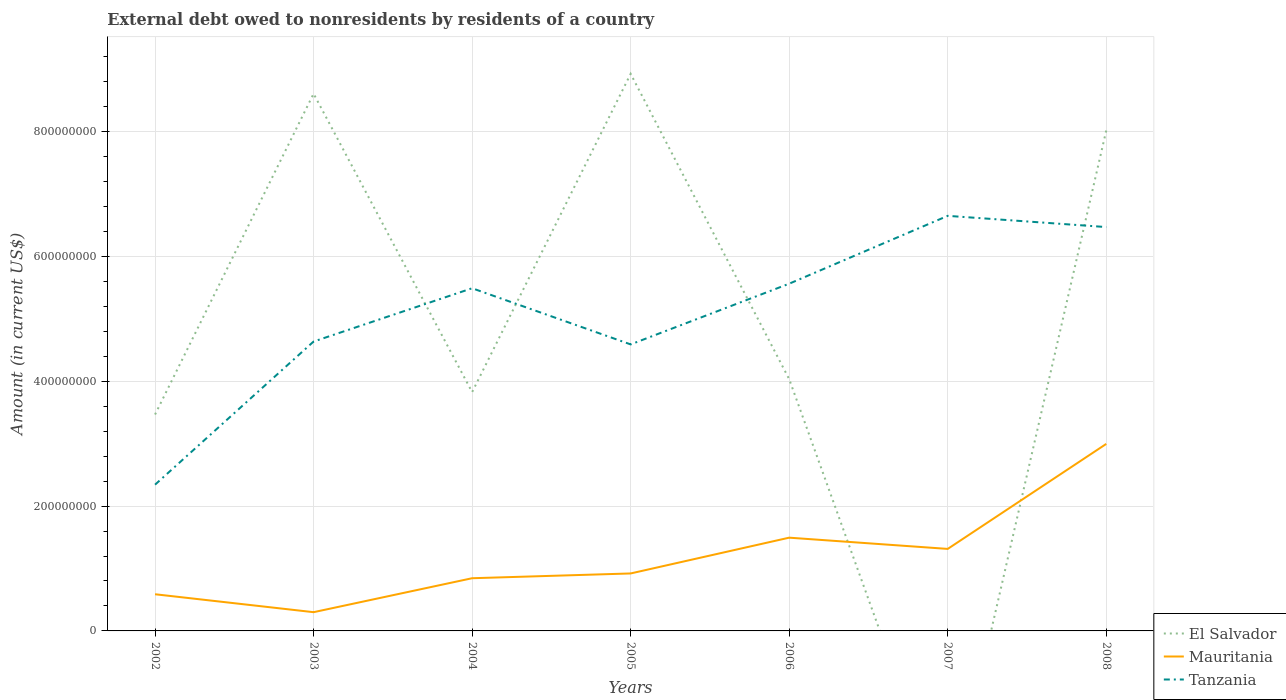How many different coloured lines are there?
Your response must be concise. 3. Does the line corresponding to Tanzania intersect with the line corresponding to Mauritania?
Keep it short and to the point. No. Is the number of lines equal to the number of legend labels?
Make the answer very short. No. Across all years, what is the maximum external debt owed by residents in Tanzania?
Your answer should be compact. 2.34e+08. What is the total external debt owed by residents in Mauritania in the graph?
Your answer should be very brief. -1.68e+08. What is the difference between the highest and the second highest external debt owed by residents in Mauritania?
Offer a very short reply. 2.70e+08. Is the external debt owed by residents in El Salvador strictly greater than the external debt owed by residents in Mauritania over the years?
Your response must be concise. No. How many lines are there?
Provide a short and direct response. 3. What is the difference between two consecutive major ticks on the Y-axis?
Provide a succinct answer. 2.00e+08. Does the graph contain any zero values?
Ensure brevity in your answer.  Yes. Where does the legend appear in the graph?
Provide a succinct answer. Bottom right. How many legend labels are there?
Ensure brevity in your answer.  3. What is the title of the graph?
Your answer should be very brief. External debt owed to nonresidents by residents of a country. What is the label or title of the Y-axis?
Offer a terse response. Amount (in current US$). What is the Amount (in current US$) of El Salvador in 2002?
Offer a very short reply. 3.47e+08. What is the Amount (in current US$) of Mauritania in 2002?
Give a very brief answer. 5.87e+07. What is the Amount (in current US$) in Tanzania in 2002?
Your answer should be very brief. 2.34e+08. What is the Amount (in current US$) in El Salvador in 2003?
Ensure brevity in your answer.  8.61e+08. What is the Amount (in current US$) of Mauritania in 2003?
Your answer should be compact. 3.00e+07. What is the Amount (in current US$) of Tanzania in 2003?
Ensure brevity in your answer.  4.64e+08. What is the Amount (in current US$) of El Salvador in 2004?
Keep it short and to the point. 3.83e+08. What is the Amount (in current US$) in Mauritania in 2004?
Keep it short and to the point. 8.44e+07. What is the Amount (in current US$) of Tanzania in 2004?
Provide a succinct answer. 5.49e+08. What is the Amount (in current US$) in El Salvador in 2005?
Make the answer very short. 8.92e+08. What is the Amount (in current US$) of Mauritania in 2005?
Keep it short and to the point. 9.21e+07. What is the Amount (in current US$) of Tanzania in 2005?
Your answer should be compact. 4.59e+08. What is the Amount (in current US$) in El Salvador in 2006?
Give a very brief answer. 4.03e+08. What is the Amount (in current US$) of Mauritania in 2006?
Offer a very short reply. 1.49e+08. What is the Amount (in current US$) in Tanzania in 2006?
Your answer should be compact. 5.56e+08. What is the Amount (in current US$) in El Salvador in 2007?
Your response must be concise. 0. What is the Amount (in current US$) of Mauritania in 2007?
Offer a very short reply. 1.31e+08. What is the Amount (in current US$) in Tanzania in 2007?
Your response must be concise. 6.65e+08. What is the Amount (in current US$) of El Salvador in 2008?
Make the answer very short. 8.02e+08. What is the Amount (in current US$) of Mauritania in 2008?
Your response must be concise. 3.00e+08. What is the Amount (in current US$) in Tanzania in 2008?
Keep it short and to the point. 6.47e+08. Across all years, what is the maximum Amount (in current US$) in El Salvador?
Your answer should be very brief. 8.92e+08. Across all years, what is the maximum Amount (in current US$) in Mauritania?
Make the answer very short. 3.00e+08. Across all years, what is the maximum Amount (in current US$) in Tanzania?
Provide a short and direct response. 6.65e+08. Across all years, what is the minimum Amount (in current US$) in Mauritania?
Provide a short and direct response. 3.00e+07. Across all years, what is the minimum Amount (in current US$) in Tanzania?
Ensure brevity in your answer.  2.34e+08. What is the total Amount (in current US$) in El Salvador in the graph?
Offer a very short reply. 3.69e+09. What is the total Amount (in current US$) of Mauritania in the graph?
Your response must be concise. 8.46e+08. What is the total Amount (in current US$) in Tanzania in the graph?
Offer a very short reply. 3.57e+09. What is the difference between the Amount (in current US$) in El Salvador in 2002 and that in 2003?
Provide a short and direct response. -5.14e+08. What is the difference between the Amount (in current US$) in Mauritania in 2002 and that in 2003?
Give a very brief answer. 2.87e+07. What is the difference between the Amount (in current US$) in Tanzania in 2002 and that in 2003?
Your answer should be compact. -2.29e+08. What is the difference between the Amount (in current US$) in El Salvador in 2002 and that in 2004?
Provide a short and direct response. -3.59e+07. What is the difference between the Amount (in current US$) of Mauritania in 2002 and that in 2004?
Make the answer very short. -2.57e+07. What is the difference between the Amount (in current US$) in Tanzania in 2002 and that in 2004?
Keep it short and to the point. -3.15e+08. What is the difference between the Amount (in current US$) of El Salvador in 2002 and that in 2005?
Your response must be concise. -5.46e+08. What is the difference between the Amount (in current US$) in Mauritania in 2002 and that in 2005?
Make the answer very short. -3.33e+07. What is the difference between the Amount (in current US$) of Tanzania in 2002 and that in 2005?
Provide a short and direct response. -2.25e+08. What is the difference between the Amount (in current US$) of El Salvador in 2002 and that in 2006?
Give a very brief answer. -5.66e+07. What is the difference between the Amount (in current US$) of Mauritania in 2002 and that in 2006?
Provide a short and direct response. -9.06e+07. What is the difference between the Amount (in current US$) in Tanzania in 2002 and that in 2006?
Provide a short and direct response. -3.22e+08. What is the difference between the Amount (in current US$) of Mauritania in 2002 and that in 2007?
Your answer should be very brief. -7.26e+07. What is the difference between the Amount (in current US$) in Tanzania in 2002 and that in 2007?
Ensure brevity in your answer.  -4.31e+08. What is the difference between the Amount (in current US$) in El Salvador in 2002 and that in 2008?
Your response must be concise. -4.55e+08. What is the difference between the Amount (in current US$) in Mauritania in 2002 and that in 2008?
Your answer should be compact. -2.41e+08. What is the difference between the Amount (in current US$) in Tanzania in 2002 and that in 2008?
Provide a short and direct response. -4.13e+08. What is the difference between the Amount (in current US$) in El Salvador in 2003 and that in 2004?
Give a very brief answer. 4.78e+08. What is the difference between the Amount (in current US$) in Mauritania in 2003 and that in 2004?
Give a very brief answer. -5.44e+07. What is the difference between the Amount (in current US$) of Tanzania in 2003 and that in 2004?
Your answer should be very brief. -8.54e+07. What is the difference between the Amount (in current US$) of El Salvador in 2003 and that in 2005?
Make the answer very short. -3.18e+07. What is the difference between the Amount (in current US$) of Mauritania in 2003 and that in 2005?
Make the answer very short. -6.20e+07. What is the difference between the Amount (in current US$) in Tanzania in 2003 and that in 2005?
Your answer should be very brief. 4.60e+06. What is the difference between the Amount (in current US$) in El Salvador in 2003 and that in 2006?
Give a very brief answer. 4.57e+08. What is the difference between the Amount (in current US$) of Mauritania in 2003 and that in 2006?
Make the answer very short. -1.19e+08. What is the difference between the Amount (in current US$) of Tanzania in 2003 and that in 2006?
Make the answer very short. -9.27e+07. What is the difference between the Amount (in current US$) of Mauritania in 2003 and that in 2007?
Give a very brief answer. -1.01e+08. What is the difference between the Amount (in current US$) in Tanzania in 2003 and that in 2007?
Your answer should be very brief. -2.01e+08. What is the difference between the Amount (in current US$) of El Salvador in 2003 and that in 2008?
Keep it short and to the point. 5.88e+07. What is the difference between the Amount (in current US$) of Mauritania in 2003 and that in 2008?
Ensure brevity in your answer.  -2.70e+08. What is the difference between the Amount (in current US$) in Tanzania in 2003 and that in 2008?
Ensure brevity in your answer.  -1.83e+08. What is the difference between the Amount (in current US$) in El Salvador in 2004 and that in 2005?
Your response must be concise. -5.10e+08. What is the difference between the Amount (in current US$) of Mauritania in 2004 and that in 2005?
Provide a short and direct response. -7.65e+06. What is the difference between the Amount (in current US$) in Tanzania in 2004 and that in 2005?
Offer a terse response. 9.00e+07. What is the difference between the Amount (in current US$) of El Salvador in 2004 and that in 2006?
Give a very brief answer. -2.07e+07. What is the difference between the Amount (in current US$) in Mauritania in 2004 and that in 2006?
Offer a terse response. -6.50e+07. What is the difference between the Amount (in current US$) in Tanzania in 2004 and that in 2006?
Keep it short and to the point. -7.30e+06. What is the difference between the Amount (in current US$) of Mauritania in 2004 and that in 2007?
Your response must be concise. -4.70e+07. What is the difference between the Amount (in current US$) of Tanzania in 2004 and that in 2007?
Offer a very short reply. -1.16e+08. What is the difference between the Amount (in current US$) in El Salvador in 2004 and that in 2008?
Provide a succinct answer. -4.19e+08. What is the difference between the Amount (in current US$) of Mauritania in 2004 and that in 2008?
Offer a terse response. -2.15e+08. What is the difference between the Amount (in current US$) in Tanzania in 2004 and that in 2008?
Your answer should be very brief. -9.80e+07. What is the difference between the Amount (in current US$) in El Salvador in 2005 and that in 2006?
Offer a very short reply. 4.89e+08. What is the difference between the Amount (in current US$) in Mauritania in 2005 and that in 2006?
Make the answer very short. -5.73e+07. What is the difference between the Amount (in current US$) of Tanzania in 2005 and that in 2006?
Provide a succinct answer. -9.73e+07. What is the difference between the Amount (in current US$) of Mauritania in 2005 and that in 2007?
Provide a short and direct response. -3.93e+07. What is the difference between the Amount (in current US$) in Tanzania in 2005 and that in 2007?
Your answer should be compact. -2.06e+08. What is the difference between the Amount (in current US$) of El Salvador in 2005 and that in 2008?
Your answer should be very brief. 9.06e+07. What is the difference between the Amount (in current US$) in Mauritania in 2005 and that in 2008?
Your answer should be compact. -2.08e+08. What is the difference between the Amount (in current US$) in Tanzania in 2005 and that in 2008?
Ensure brevity in your answer.  -1.88e+08. What is the difference between the Amount (in current US$) in Mauritania in 2006 and that in 2007?
Offer a terse response. 1.80e+07. What is the difference between the Amount (in current US$) of Tanzania in 2006 and that in 2007?
Provide a short and direct response. -1.09e+08. What is the difference between the Amount (in current US$) in El Salvador in 2006 and that in 2008?
Provide a short and direct response. -3.98e+08. What is the difference between the Amount (in current US$) in Mauritania in 2006 and that in 2008?
Your answer should be compact. -1.50e+08. What is the difference between the Amount (in current US$) in Tanzania in 2006 and that in 2008?
Your answer should be very brief. -9.07e+07. What is the difference between the Amount (in current US$) of Mauritania in 2007 and that in 2008?
Offer a very short reply. -1.68e+08. What is the difference between the Amount (in current US$) of Tanzania in 2007 and that in 2008?
Your answer should be very brief. 1.80e+07. What is the difference between the Amount (in current US$) of El Salvador in 2002 and the Amount (in current US$) of Mauritania in 2003?
Provide a short and direct response. 3.17e+08. What is the difference between the Amount (in current US$) in El Salvador in 2002 and the Amount (in current US$) in Tanzania in 2003?
Offer a very short reply. -1.17e+08. What is the difference between the Amount (in current US$) of Mauritania in 2002 and the Amount (in current US$) of Tanzania in 2003?
Keep it short and to the point. -4.05e+08. What is the difference between the Amount (in current US$) of El Salvador in 2002 and the Amount (in current US$) of Mauritania in 2004?
Offer a terse response. 2.62e+08. What is the difference between the Amount (in current US$) in El Salvador in 2002 and the Amount (in current US$) in Tanzania in 2004?
Provide a succinct answer. -2.02e+08. What is the difference between the Amount (in current US$) of Mauritania in 2002 and the Amount (in current US$) of Tanzania in 2004?
Offer a very short reply. -4.90e+08. What is the difference between the Amount (in current US$) in El Salvador in 2002 and the Amount (in current US$) in Mauritania in 2005?
Ensure brevity in your answer.  2.55e+08. What is the difference between the Amount (in current US$) in El Salvador in 2002 and the Amount (in current US$) in Tanzania in 2005?
Your answer should be compact. -1.12e+08. What is the difference between the Amount (in current US$) in Mauritania in 2002 and the Amount (in current US$) in Tanzania in 2005?
Your answer should be compact. -4.00e+08. What is the difference between the Amount (in current US$) of El Salvador in 2002 and the Amount (in current US$) of Mauritania in 2006?
Your answer should be very brief. 1.97e+08. What is the difference between the Amount (in current US$) of El Salvador in 2002 and the Amount (in current US$) of Tanzania in 2006?
Your response must be concise. -2.10e+08. What is the difference between the Amount (in current US$) in Mauritania in 2002 and the Amount (in current US$) in Tanzania in 2006?
Ensure brevity in your answer.  -4.97e+08. What is the difference between the Amount (in current US$) of El Salvador in 2002 and the Amount (in current US$) of Mauritania in 2007?
Offer a terse response. 2.15e+08. What is the difference between the Amount (in current US$) in El Salvador in 2002 and the Amount (in current US$) in Tanzania in 2007?
Make the answer very short. -3.18e+08. What is the difference between the Amount (in current US$) in Mauritania in 2002 and the Amount (in current US$) in Tanzania in 2007?
Provide a short and direct response. -6.06e+08. What is the difference between the Amount (in current US$) in El Salvador in 2002 and the Amount (in current US$) in Mauritania in 2008?
Offer a terse response. 4.71e+07. What is the difference between the Amount (in current US$) of El Salvador in 2002 and the Amount (in current US$) of Tanzania in 2008?
Give a very brief answer. -3.00e+08. What is the difference between the Amount (in current US$) of Mauritania in 2002 and the Amount (in current US$) of Tanzania in 2008?
Ensure brevity in your answer.  -5.88e+08. What is the difference between the Amount (in current US$) of El Salvador in 2003 and the Amount (in current US$) of Mauritania in 2004?
Provide a succinct answer. 7.76e+08. What is the difference between the Amount (in current US$) of El Salvador in 2003 and the Amount (in current US$) of Tanzania in 2004?
Your response must be concise. 3.12e+08. What is the difference between the Amount (in current US$) of Mauritania in 2003 and the Amount (in current US$) of Tanzania in 2004?
Provide a succinct answer. -5.19e+08. What is the difference between the Amount (in current US$) in El Salvador in 2003 and the Amount (in current US$) in Mauritania in 2005?
Your answer should be compact. 7.69e+08. What is the difference between the Amount (in current US$) in El Salvador in 2003 and the Amount (in current US$) in Tanzania in 2005?
Provide a short and direct response. 4.02e+08. What is the difference between the Amount (in current US$) of Mauritania in 2003 and the Amount (in current US$) of Tanzania in 2005?
Make the answer very short. -4.29e+08. What is the difference between the Amount (in current US$) of El Salvador in 2003 and the Amount (in current US$) of Mauritania in 2006?
Your answer should be very brief. 7.11e+08. What is the difference between the Amount (in current US$) of El Salvador in 2003 and the Amount (in current US$) of Tanzania in 2006?
Provide a succinct answer. 3.04e+08. What is the difference between the Amount (in current US$) in Mauritania in 2003 and the Amount (in current US$) in Tanzania in 2006?
Offer a terse response. -5.26e+08. What is the difference between the Amount (in current US$) in El Salvador in 2003 and the Amount (in current US$) in Mauritania in 2007?
Offer a terse response. 7.29e+08. What is the difference between the Amount (in current US$) in El Salvador in 2003 and the Amount (in current US$) in Tanzania in 2007?
Your answer should be compact. 1.96e+08. What is the difference between the Amount (in current US$) of Mauritania in 2003 and the Amount (in current US$) of Tanzania in 2007?
Your answer should be compact. -6.35e+08. What is the difference between the Amount (in current US$) in El Salvador in 2003 and the Amount (in current US$) in Mauritania in 2008?
Provide a short and direct response. 5.61e+08. What is the difference between the Amount (in current US$) in El Salvador in 2003 and the Amount (in current US$) in Tanzania in 2008?
Ensure brevity in your answer.  2.14e+08. What is the difference between the Amount (in current US$) of Mauritania in 2003 and the Amount (in current US$) of Tanzania in 2008?
Make the answer very short. -6.17e+08. What is the difference between the Amount (in current US$) of El Salvador in 2004 and the Amount (in current US$) of Mauritania in 2005?
Keep it short and to the point. 2.91e+08. What is the difference between the Amount (in current US$) in El Salvador in 2004 and the Amount (in current US$) in Tanzania in 2005?
Give a very brief answer. -7.64e+07. What is the difference between the Amount (in current US$) of Mauritania in 2004 and the Amount (in current US$) of Tanzania in 2005?
Offer a terse response. -3.75e+08. What is the difference between the Amount (in current US$) in El Salvador in 2004 and the Amount (in current US$) in Mauritania in 2006?
Your response must be concise. 2.33e+08. What is the difference between the Amount (in current US$) of El Salvador in 2004 and the Amount (in current US$) of Tanzania in 2006?
Ensure brevity in your answer.  -1.74e+08. What is the difference between the Amount (in current US$) of Mauritania in 2004 and the Amount (in current US$) of Tanzania in 2006?
Provide a succinct answer. -4.72e+08. What is the difference between the Amount (in current US$) of El Salvador in 2004 and the Amount (in current US$) of Mauritania in 2007?
Your answer should be compact. 2.51e+08. What is the difference between the Amount (in current US$) in El Salvador in 2004 and the Amount (in current US$) in Tanzania in 2007?
Keep it short and to the point. -2.82e+08. What is the difference between the Amount (in current US$) in Mauritania in 2004 and the Amount (in current US$) in Tanzania in 2007?
Provide a short and direct response. -5.81e+08. What is the difference between the Amount (in current US$) in El Salvador in 2004 and the Amount (in current US$) in Mauritania in 2008?
Your answer should be very brief. 8.30e+07. What is the difference between the Amount (in current US$) in El Salvador in 2004 and the Amount (in current US$) in Tanzania in 2008?
Make the answer very short. -2.64e+08. What is the difference between the Amount (in current US$) of Mauritania in 2004 and the Amount (in current US$) of Tanzania in 2008?
Provide a short and direct response. -5.63e+08. What is the difference between the Amount (in current US$) of El Salvador in 2005 and the Amount (in current US$) of Mauritania in 2006?
Give a very brief answer. 7.43e+08. What is the difference between the Amount (in current US$) in El Salvador in 2005 and the Amount (in current US$) in Tanzania in 2006?
Make the answer very short. 3.36e+08. What is the difference between the Amount (in current US$) of Mauritania in 2005 and the Amount (in current US$) of Tanzania in 2006?
Offer a very short reply. -4.64e+08. What is the difference between the Amount (in current US$) of El Salvador in 2005 and the Amount (in current US$) of Mauritania in 2007?
Offer a terse response. 7.61e+08. What is the difference between the Amount (in current US$) of El Salvador in 2005 and the Amount (in current US$) of Tanzania in 2007?
Provide a short and direct response. 2.27e+08. What is the difference between the Amount (in current US$) in Mauritania in 2005 and the Amount (in current US$) in Tanzania in 2007?
Make the answer very short. -5.73e+08. What is the difference between the Amount (in current US$) of El Salvador in 2005 and the Amount (in current US$) of Mauritania in 2008?
Your answer should be very brief. 5.93e+08. What is the difference between the Amount (in current US$) in El Salvador in 2005 and the Amount (in current US$) in Tanzania in 2008?
Your answer should be very brief. 2.45e+08. What is the difference between the Amount (in current US$) in Mauritania in 2005 and the Amount (in current US$) in Tanzania in 2008?
Your answer should be compact. -5.55e+08. What is the difference between the Amount (in current US$) of El Salvador in 2006 and the Amount (in current US$) of Mauritania in 2007?
Give a very brief answer. 2.72e+08. What is the difference between the Amount (in current US$) in El Salvador in 2006 and the Amount (in current US$) in Tanzania in 2007?
Make the answer very short. -2.62e+08. What is the difference between the Amount (in current US$) in Mauritania in 2006 and the Amount (in current US$) in Tanzania in 2007?
Provide a succinct answer. -5.16e+08. What is the difference between the Amount (in current US$) of El Salvador in 2006 and the Amount (in current US$) of Mauritania in 2008?
Ensure brevity in your answer.  1.04e+08. What is the difference between the Amount (in current US$) of El Salvador in 2006 and the Amount (in current US$) of Tanzania in 2008?
Your response must be concise. -2.44e+08. What is the difference between the Amount (in current US$) of Mauritania in 2006 and the Amount (in current US$) of Tanzania in 2008?
Offer a very short reply. -4.98e+08. What is the difference between the Amount (in current US$) of Mauritania in 2007 and the Amount (in current US$) of Tanzania in 2008?
Your answer should be very brief. -5.16e+08. What is the average Amount (in current US$) of El Salvador per year?
Your answer should be very brief. 5.27e+08. What is the average Amount (in current US$) in Mauritania per year?
Ensure brevity in your answer.  1.21e+08. What is the average Amount (in current US$) of Tanzania per year?
Your response must be concise. 5.11e+08. In the year 2002, what is the difference between the Amount (in current US$) of El Salvador and Amount (in current US$) of Mauritania?
Your answer should be compact. 2.88e+08. In the year 2002, what is the difference between the Amount (in current US$) of El Salvador and Amount (in current US$) of Tanzania?
Offer a very short reply. 1.12e+08. In the year 2002, what is the difference between the Amount (in current US$) in Mauritania and Amount (in current US$) in Tanzania?
Your response must be concise. -1.76e+08. In the year 2003, what is the difference between the Amount (in current US$) of El Salvador and Amount (in current US$) of Mauritania?
Offer a very short reply. 8.31e+08. In the year 2003, what is the difference between the Amount (in current US$) in El Salvador and Amount (in current US$) in Tanzania?
Provide a short and direct response. 3.97e+08. In the year 2003, what is the difference between the Amount (in current US$) of Mauritania and Amount (in current US$) of Tanzania?
Offer a terse response. -4.34e+08. In the year 2004, what is the difference between the Amount (in current US$) of El Salvador and Amount (in current US$) of Mauritania?
Ensure brevity in your answer.  2.98e+08. In the year 2004, what is the difference between the Amount (in current US$) in El Salvador and Amount (in current US$) in Tanzania?
Make the answer very short. -1.66e+08. In the year 2004, what is the difference between the Amount (in current US$) of Mauritania and Amount (in current US$) of Tanzania?
Provide a short and direct response. -4.65e+08. In the year 2005, what is the difference between the Amount (in current US$) of El Salvador and Amount (in current US$) of Mauritania?
Provide a short and direct response. 8.00e+08. In the year 2005, what is the difference between the Amount (in current US$) in El Salvador and Amount (in current US$) in Tanzania?
Offer a very short reply. 4.33e+08. In the year 2005, what is the difference between the Amount (in current US$) of Mauritania and Amount (in current US$) of Tanzania?
Offer a very short reply. -3.67e+08. In the year 2006, what is the difference between the Amount (in current US$) of El Salvador and Amount (in current US$) of Mauritania?
Give a very brief answer. 2.54e+08. In the year 2006, what is the difference between the Amount (in current US$) in El Salvador and Amount (in current US$) in Tanzania?
Make the answer very short. -1.53e+08. In the year 2006, what is the difference between the Amount (in current US$) of Mauritania and Amount (in current US$) of Tanzania?
Offer a very short reply. -4.07e+08. In the year 2007, what is the difference between the Amount (in current US$) of Mauritania and Amount (in current US$) of Tanzania?
Ensure brevity in your answer.  -5.34e+08. In the year 2008, what is the difference between the Amount (in current US$) in El Salvador and Amount (in current US$) in Mauritania?
Make the answer very short. 5.02e+08. In the year 2008, what is the difference between the Amount (in current US$) of El Salvador and Amount (in current US$) of Tanzania?
Your answer should be compact. 1.55e+08. In the year 2008, what is the difference between the Amount (in current US$) in Mauritania and Amount (in current US$) in Tanzania?
Keep it short and to the point. -3.47e+08. What is the ratio of the Amount (in current US$) in El Salvador in 2002 to that in 2003?
Your answer should be very brief. 0.4. What is the ratio of the Amount (in current US$) of Mauritania in 2002 to that in 2003?
Give a very brief answer. 1.96. What is the ratio of the Amount (in current US$) in Tanzania in 2002 to that in 2003?
Ensure brevity in your answer.  0.51. What is the ratio of the Amount (in current US$) of El Salvador in 2002 to that in 2004?
Offer a very short reply. 0.91. What is the ratio of the Amount (in current US$) in Mauritania in 2002 to that in 2004?
Offer a very short reply. 0.7. What is the ratio of the Amount (in current US$) of Tanzania in 2002 to that in 2004?
Keep it short and to the point. 0.43. What is the ratio of the Amount (in current US$) in El Salvador in 2002 to that in 2005?
Provide a succinct answer. 0.39. What is the ratio of the Amount (in current US$) in Mauritania in 2002 to that in 2005?
Your response must be concise. 0.64. What is the ratio of the Amount (in current US$) in Tanzania in 2002 to that in 2005?
Provide a succinct answer. 0.51. What is the ratio of the Amount (in current US$) in El Salvador in 2002 to that in 2006?
Keep it short and to the point. 0.86. What is the ratio of the Amount (in current US$) of Mauritania in 2002 to that in 2006?
Your response must be concise. 0.39. What is the ratio of the Amount (in current US$) of Tanzania in 2002 to that in 2006?
Offer a very short reply. 0.42. What is the ratio of the Amount (in current US$) of Mauritania in 2002 to that in 2007?
Keep it short and to the point. 0.45. What is the ratio of the Amount (in current US$) in Tanzania in 2002 to that in 2007?
Provide a short and direct response. 0.35. What is the ratio of the Amount (in current US$) in El Salvador in 2002 to that in 2008?
Provide a short and direct response. 0.43. What is the ratio of the Amount (in current US$) in Mauritania in 2002 to that in 2008?
Make the answer very short. 0.2. What is the ratio of the Amount (in current US$) of Tanzania in 2002 to that in 2008?
Your answer should be compact. 0.36. What is the ratio of the Amount (in current US$) in El Salvador in 2003 to that in 2004?
Offer a very short reply. 2.25. What is the ratio of the Amount (in current US$) in Mauritania in 2003 to that in 2004?
Keep it short and to the point. 0.36. What is the ratio of the Amount (in current US$) in Tanzania in 2003 to that in 2004?
Your answer should be very brief. 0.84. What is the ratio of the Amount (in current US$) of El Salvador in 2003 to that in 2005?
Your answer should be very brief. 0.96. What is the ratio of the Amount (in current US$) in Mauritania in 2003 to that in 2005?
Offer a very short reply. 0.33. What is the ratio of the Amount (in current US$) of El Salvador in 2003 to that in 2006?
Provide a succinct answer. 2.13. What is the ratio of the Amount (in current US$) of Mauritania in 2003 to that in 2006?
Offer a terse response. 0.2. What is the ratio of the Amount (in current US$) in Tanzania in 2003 to that in 2006?
Your response must be concise. 0.83. What is the ratio of the Amount (in current US$) of Mauritania in 2003 to that in 2007?
Your answer should be compact. 0.23. What is the ratio of the Amount (in current US$) of Tanzania in 2003 to that in 2007?
Provide a short and direct response. 0.7. What is the ratio of the Amount (in current US$) of El Salvador in 2003 to that in 2008?
Offer a very short reply. 1.07. What is the ratio of the Amount (in current US$) of Mauritania in 2003 to that in 2008?
Provide a short and direct response. 0.1. What is the ratio of the Amount (in current US$) of Tanzania in 2003 to that in 2008?
Give a very brief answer. 0.72. What is the ratio of the Amount (in current US$) in El Salvador in 2004 to that in 2005?
Ensure brevity in your answer.  0.43. What is the ratio of the Amount (in current US$) of Mauritania in 2004 to that in 2005?
Give a very brief answer. 0.92. What is the ratio of the Amount (in current US$) in Tanzania in 2004 to that in 2005?
Provide a short and direct response. 1.2. What is the ratio of the Amount (in current US$) of El Salvador in 2004 to that in 2006?
Give a very brief answer. 0.95. What is the ratio of the Amount (in current US$) of Mauritania in 2004 to that in 2006?
Ensure brevity in your answer.  0.57. What is the ratio of the Amount (in current US$) in Tanzania in 2004 to that in 2006?
Make the answer very short. 0.99. What is the ratio of the Amount (in current US$) in Mauritania in 2004 to that in 2007?
Offer a very short reply. 0.64. What is the ratio of the Amount (in current US$) of Tanzania in 2004 to that in 2007?
Your response must be concise. 0.83. What is the ratio of the Amount (in current US$) in El Salvador in 2004 to that in 2008?
Ensure brevity in your answer.  0.48. What is the ratio of the Amount (in current US$) of Mauritania in 2004 to that in 2008?
Keep it short and to the point. 0.28. What is the ratio of the Amount (in current US$) of Tanzania in 2004 to that in 2008?
Provide a short and direct response. 0.85. What is the ratio of the Amount (in current US$) in El Salvador in 2005 to that in 2006?
Keep it short and to the point. 2.21. What is the ratio of the Amount (in current US$) of Mauritania in 2005 to that in 2006?
Offer a very short reply. 0.62. What is the ratio of the Amount (in current US$) of Tanzania in 2005 to that in 2006?
Provide a short and direct response. 0.83. What is the ratio of the Amount (in current US$) of Mauritania in 2005 to that in 2007?
Provide a succinct answer. 0.7. What is the ratio of the Amount (in current US$) in Tanzania in 2005 to that in 2007?
Keep it short and to the point. 0.69. What is the ratio of the Amount (in current US$) in El Salvador in 2005 to that in 2008?
Make the answer very short. 1.11. What is the ratio of the Amount (in current US$) in Mauritania in 2005 to that in 2008?
Offer a terse response. 0.31. What is the ratio of the Amount (in current US$) of Tanzania in 2005 to that in 2008?
Offer a very short reply. 0.71. What is the ratio of the Amount (in current US$) of Mauritania in 2006 to that in 2007?
Offer a very short reply. 1.14. What is the ratio of the Amount (in current US$) in Tanzania in 2006 to that in 2007?
Give a very brief answer. 0.84. What is the ratio of the Amount (in current US$) in El Salvador in 2006 to that in 2008?
Your answer should be very brief. 0.5. What is the ratio of the Amount (in current US$) in Mauritania in 2006 to that in 2008?
Ensure brevity in your answer.  0.5. What is the ratio of the Amount (in current US$) in Tanzania in 2006 to that in 2008?
Make the answer very short. 0.86. What is the ratio of the Amount (in current US$) in Mauritania in 2007 to that in 2008?
Offer a very short reply. 0.44. What is the ratio of the Amount (in current US$) of Tanzania in 2007 to that in 2008?
Your answer should be compact. 1.03. What is the difference between the highest and the second highest Amount (in current US$) in El Salvador?
Offer a terse response. 3.18e+07. What is the difference between the highest and the second highest Amount (in current US$) in Mauritania?
Your answer should be very brief. 1.50e+08. What is the difference between the highest and the second highest Amount (in current US$) in Tanzania?
Provide a succinct answer. 1.80e+07. What is the difference between the highest and the lowest Amount (in current US$) of El Salvador?
Offer a very short reply. 8.92e+08. What is the difference between the highest and the lowest Amount (in current US$) of Mauritania?
Your answer should be compact. 2.70e+08. What is the difference between the highest and the lowest Amount (in current US$) of Tanzania?
Offer a terse response. 4.31e+08. 